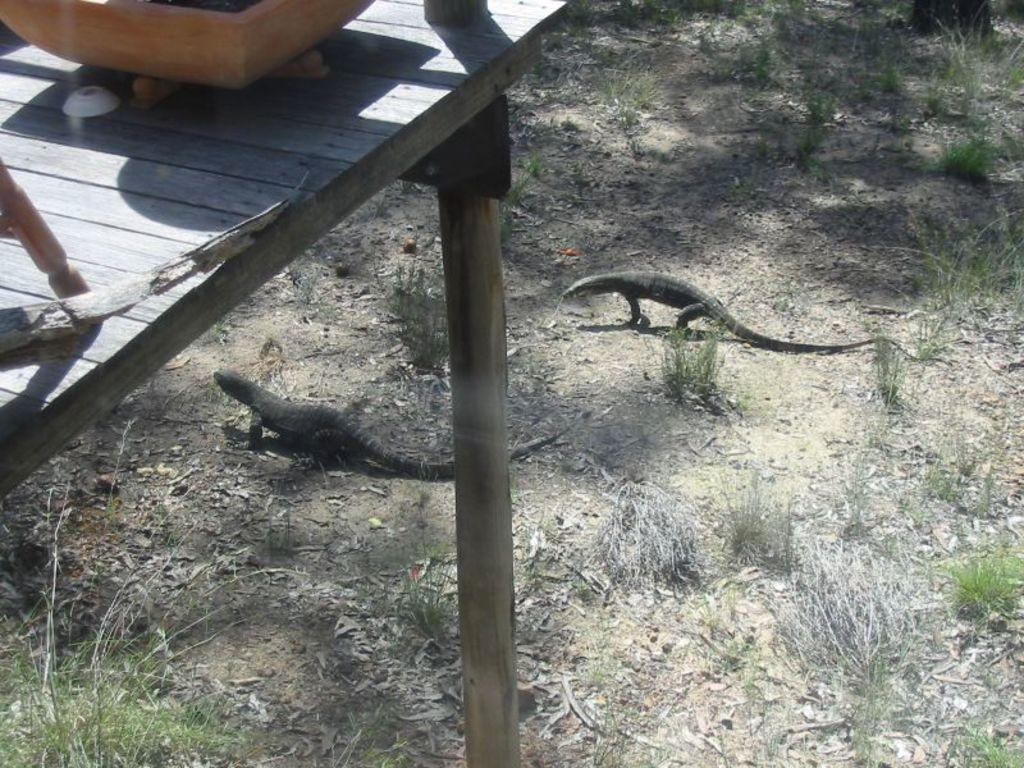What type of table is in the image? There is a wooden table in the image. What is on top of the table? There are objects on top of the table. What can be seen at the bottom of the image? Grass is visible at the bottom of the image, and dried leaves are present on the surface. How many reptiles are in the image? There are two reptiles in the image. What rhythm is the knife playing in the image? There is no knife present in the image, so it cannot be playing any rhythm. 